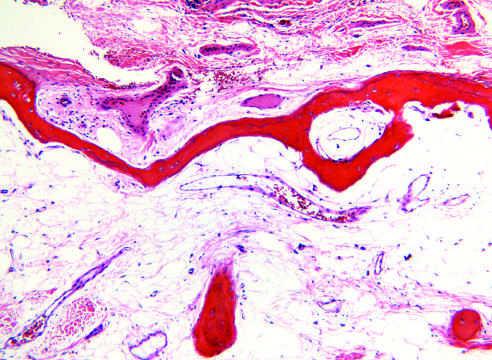what are markedly thinned?
Answer the question using a single word or phrase. The trabecular bone of the medulla and the cortical bone 